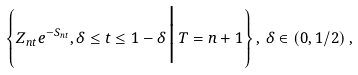<formula> <loc_0><loc_0><loc_500><loc_500>\left \{ Z _ { n t } e ^ { - S _ { n t } } , \delta \leq t \leq 1 - \delta \, \Big | \, T = n + 1 \right \} , \, \delta \in \left ( 0 , 1 / 2 \right ) ,</formula> 